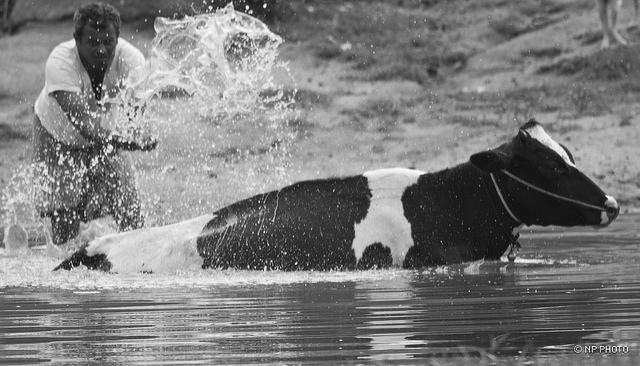Please identify all text content in this image. PHOTO NP 